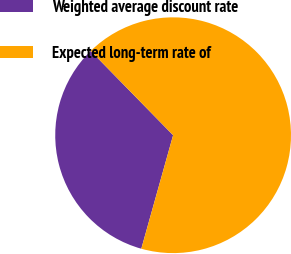Convert chart to OTSL. <chart><loc_0><loc_0><loc_500><loc_500><pie_chart><fcel>Weighted average discount rate<fcel>Expected long-term rate of<nl><fcel>33.33%<fcel>66.67%<nl></chart> 